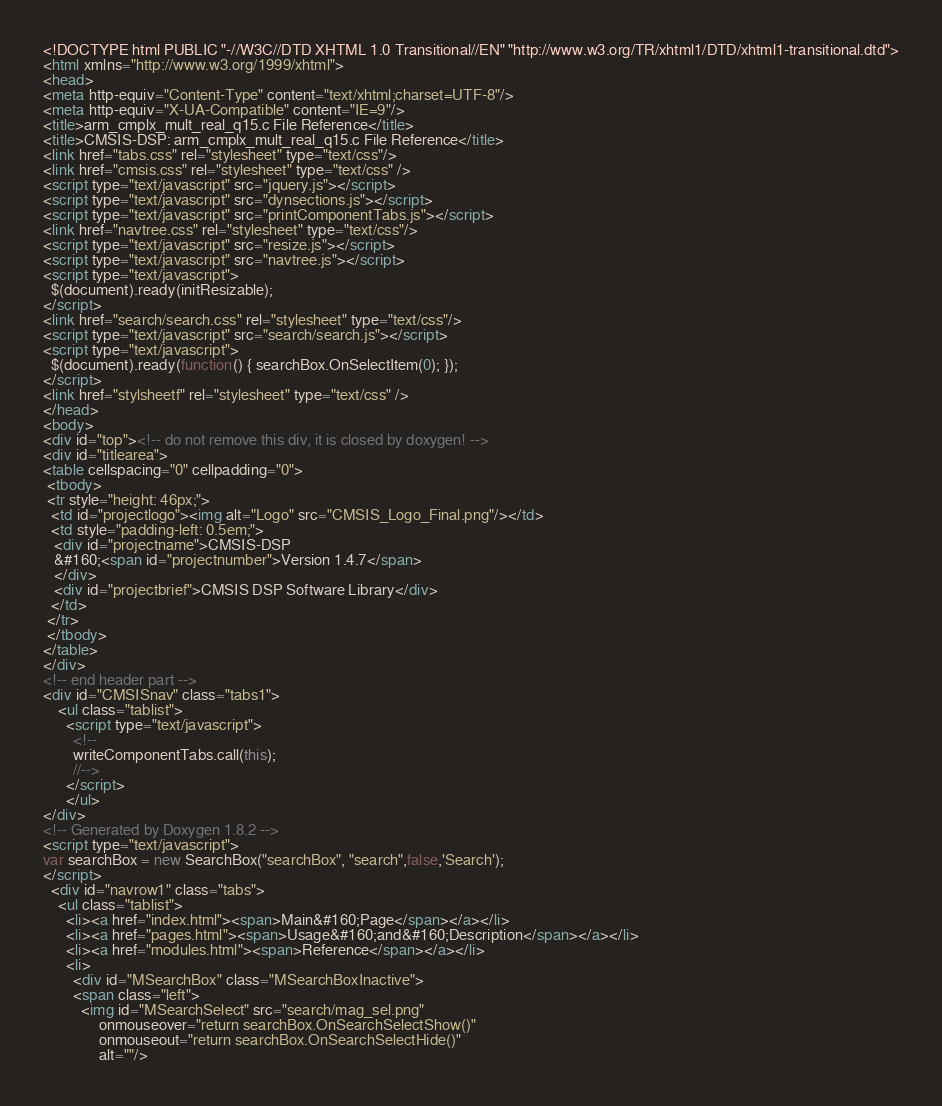<code> <loc_0><loc_0><loc_500><loc_500><_HTML_><!DOCTYPE html PUBLIC "-//W3C//DTD XHTML 1.0 Transitional//EN" "http://www.w3.org/TR/xhtml1/DTD/xhtml1-transitional.dtd">
<html xmlns="http://www.w3.org/1999/xhtml">
<head>
<meta http-equiv="Content-Type" content="text/xhtml;charset=UTF-8"/>
<meta http-equiv="X-UA-Compatible" content="IE=9"/>
<title>arm_cmplx_mult_real_q15.c File Reference</title>
<title>CMSIS-DSP: arm_cmplx_mult_real_q15.c File Reference</title>
<link href="tabs.css" rel="stylesheet" type="text/css"/>
<link href="cmsis.css" rel="stylesheet" type="text/css" />
<script type="text/javascript" src="jquery.js"></script>
<script type="text/javascript" src="dynsections.js"></script>
<script type="text/javascript" src="printComponentTabs.js"></script>
<link href="navtree.css" rel="stylesheet" type="text/css"/>
<script type="text/javascript" src="resize.js"></script>
<script type="text/javascript" src="navtree.js"></script>
<script type="text/javascript">
  $(document).ready(initResizable);
</script>
<link href="search/search.css" rel="stylesheet" type="text/css"/>
<script type="text/javascript" src="search/search.js"></script>
<script type="text/javascript">
  $(document).ready(function() { searchBox.OnSelectItem(0); });
</script>
<link href="stylsheetf" rel="stylesheet" type="text/css" />
</head>
<body>
<div id="top"><!-- do not remove this div, it is closed by doxygen! -->
<div id="titlearea">
<table cellspacing="0" cellpadding="0">
 <tbody>
 <tr style="height: 46px;">
  <td id="projectlogo"><img alt="Logo" src="CMSIS_Logo_Final.png"/></td>
  <td style="padding-left: 0.5em;">
   <div id="projectname">CMSIS-DSP
   &#160;<span id="projectnumber">Version 1.4.7</span>
   </div>
   <div id="projectbrief">CMSIS DSP Software Library</div>
  </td>
 </tr>
 </tbody>
</table>
</div>
<!-- end header part -->
<div id="CMSISnav" class="tabs1">
    <ul class="tablist">
      <script type="text/javascript">
		<!--
		writeComponentTabs.call(this);
		//-->
      </script>
	  </ul>
</div>
<!-- Generated by Doxygen 1.8.2 -->
<script type="text/javascript">
var searchBox = new SearchBox("searchBox", "search",false,'Search');
</script>
  <div id="navrow1" class="tabs">
    <ul class="tablist">
      <li><a href="index.html"><span>Main&#160;Page</span></a></li>
      <li><a href="pages.html"><span>Usage&#160;and&#160;Description</span></a></li>
      <li><a href="modules.html"><span>Reference</span></a></li>
      <li>
        <div id="MSearchBox" class="MSearchBoxInactive">
        <span class="left">
          <img id="MSearchSelect" src="search/mag_sel.png"
               onmouseover="return searchBox.OnSearchSelectShow()"
               onmouseout="return searchBox.OnSearchSelectHide()"
               alt=""/></code> 